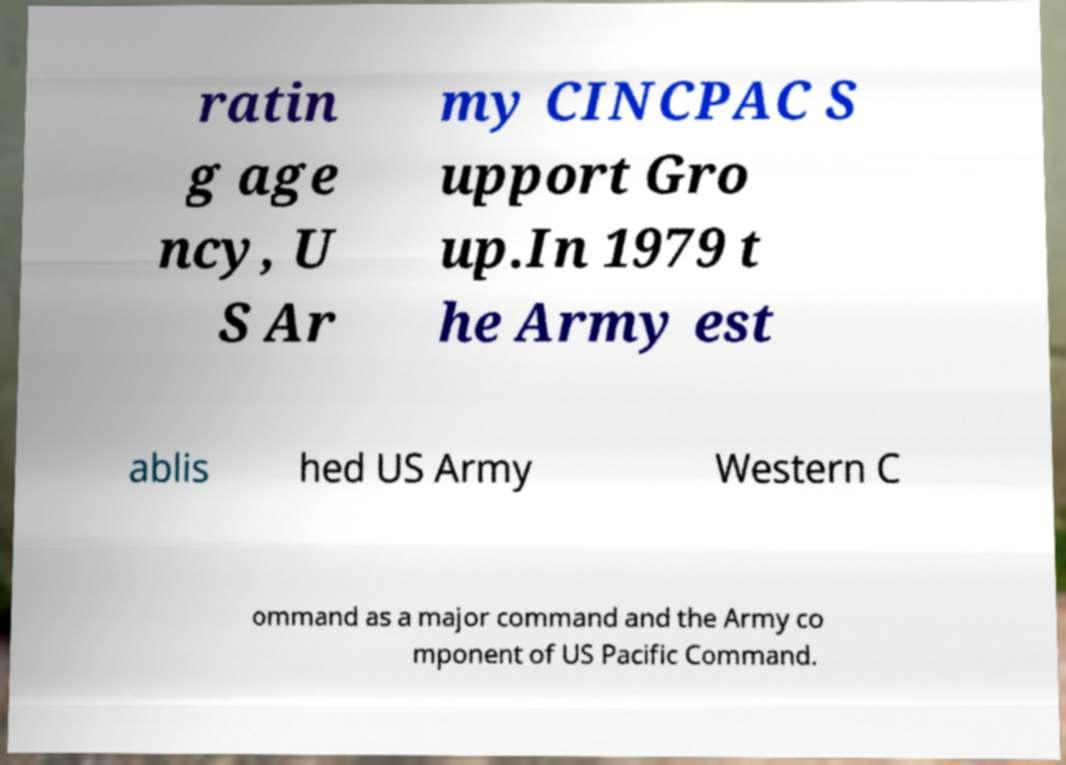Can you accurately transcribe the text from the provided image for me? ratin g age ncy, U S Ar my CINCPAC S upport Gro up.In 1979 t he Army est ablis hed US Army Western C ommand as a major command and the Army co mponent of US Pacific Command. 